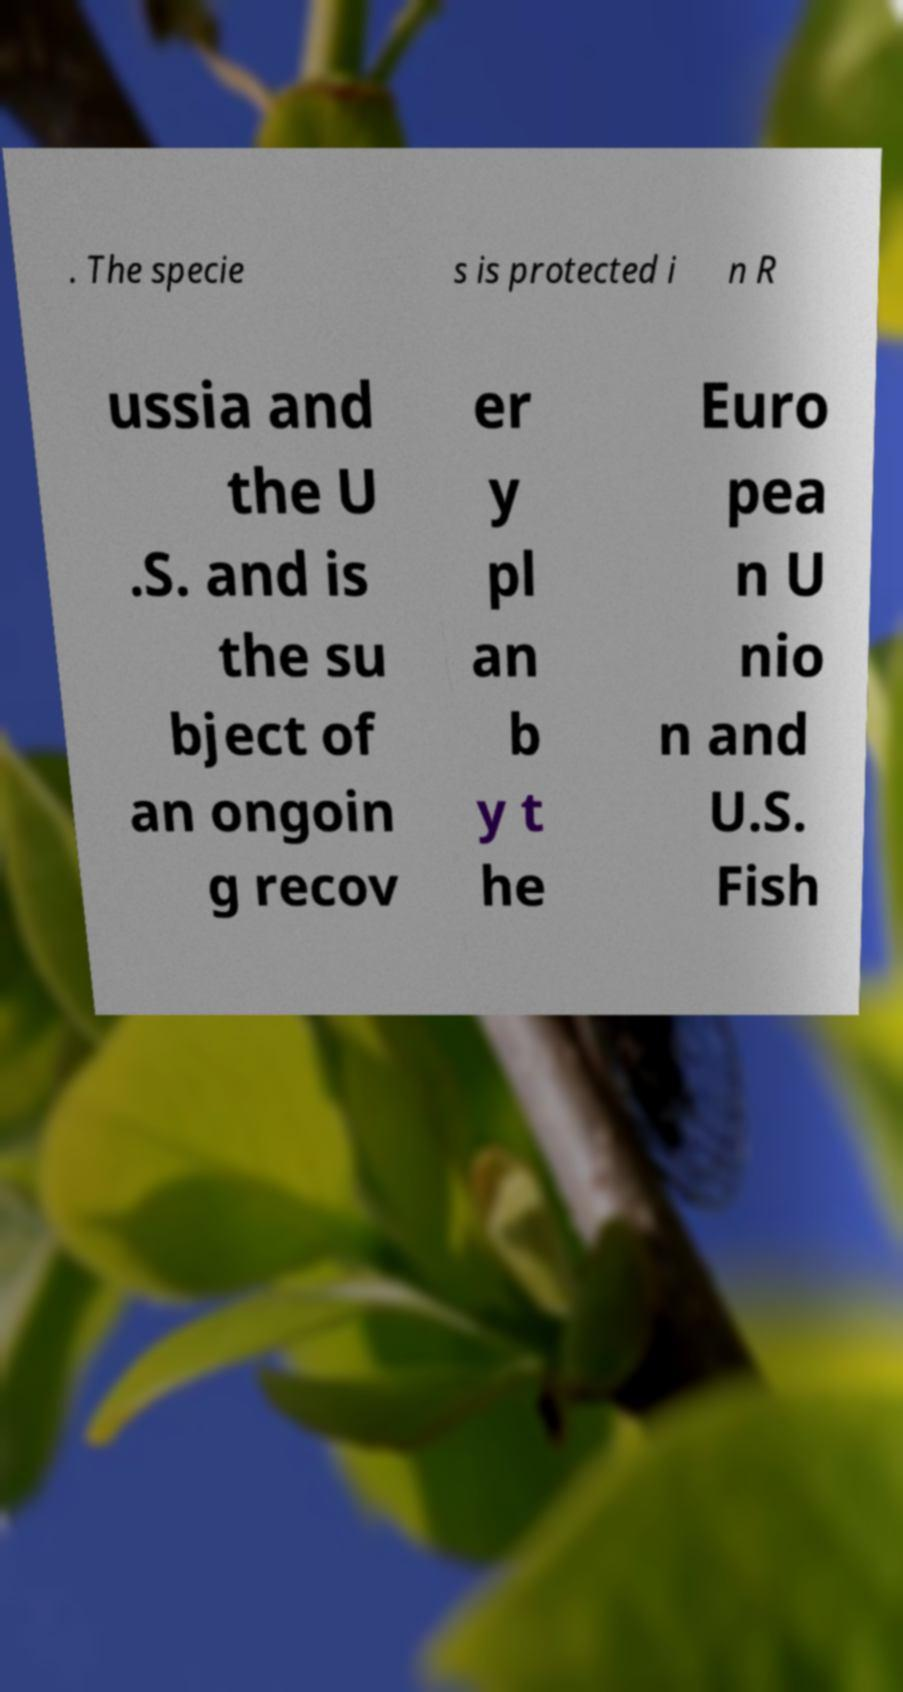Could you assist in decoding the text presented in this image and type it out clearly? . The specie s is protected i n R ussia and the U .S. and is the su bject of an ongoin g recov er y pl an b y t he Euro pea n U nio n and U.S. Fish 